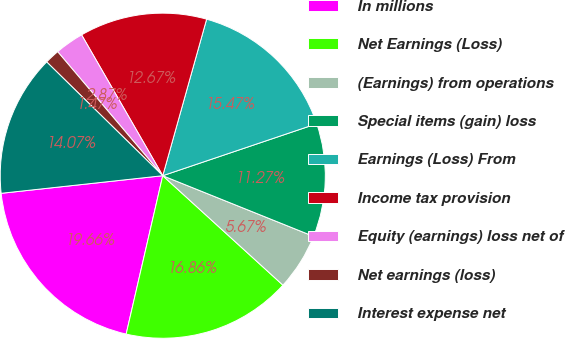Convert chart. <chart><loc_0><loc_0><loc_500><loc_500><pie_chart><fcel>In millions<fcel>Net Earnings (Loss)<fcel>(Earnings) from operations<fcel>Special items (gain) loss<fcel>Earnings (Loss) From<fcel>Income tax provision<fcel>Equity (earnings) loss net of<fcel>Net earnings (loss)<fcel>Interest expense net<nl><fcel>19.66%<fcel>16.86%<fcel>5.67%<fcel>11.27%<fcel>15.47%<fcel>12.67%<fcel>2.87%<fcel>1.47%<fcel>14.07%<nl></chart> 